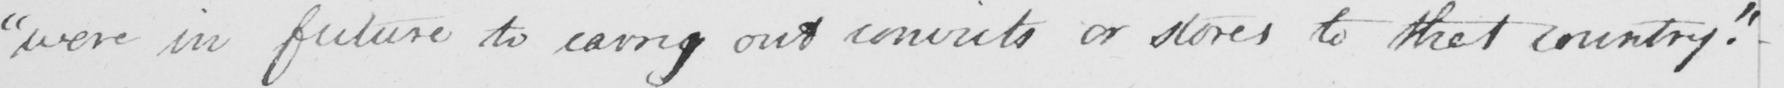What text is written in this handwritten line? " were in future to carry out convicts or stores to that country . " 